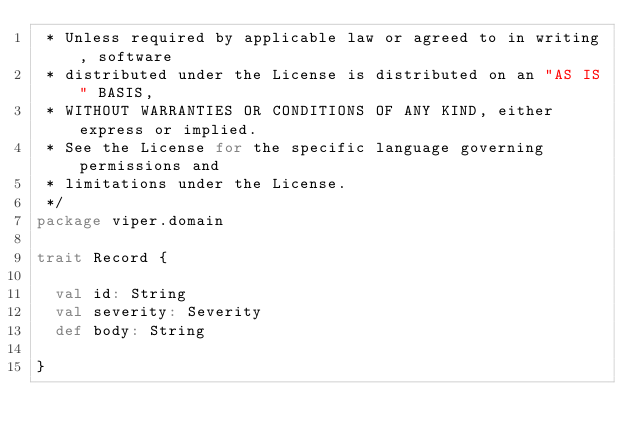<code> <loc_0><loc_0><loc_500><loc_500><_Scala_> * Unless required by applicable law or agreed to in writing, software
 * distributed under the License is distributed on an "AS IS" BASIS,
 * WITHOUT WARRANTIES OR CONDITIONS OF ANY KIND, either express or implied.
 * See the License for the specific language governing permissions and
 * limitations under the License.
 */
package viper.domain

trait Record {

  val id: String
  val severity: Severity
  def body: String

}
</code> 